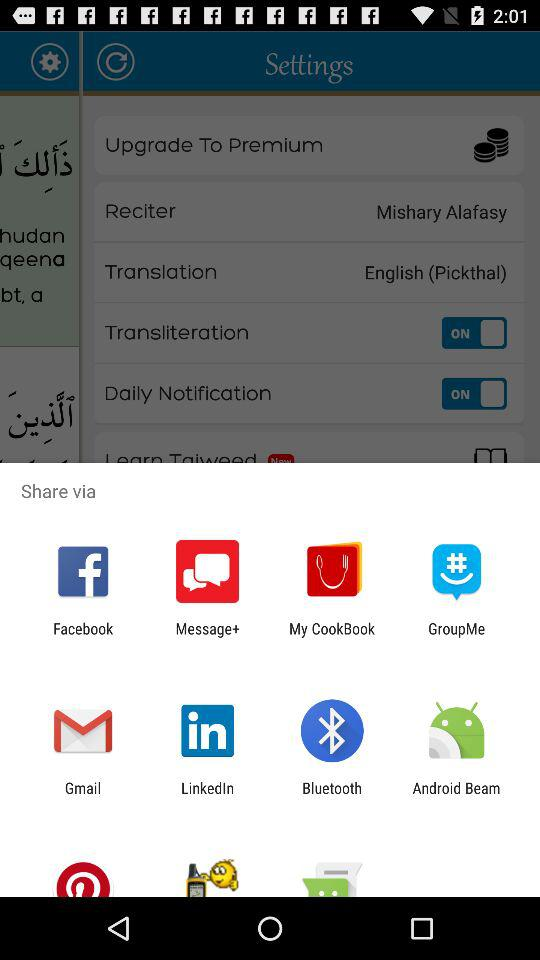What app can I use to share? You can use the apps "Facebook", "Message+", "My CookBook", "GroupMe", "Gmail", "LinkedIn", "Bluetooth" and "Android Beam" to share. 